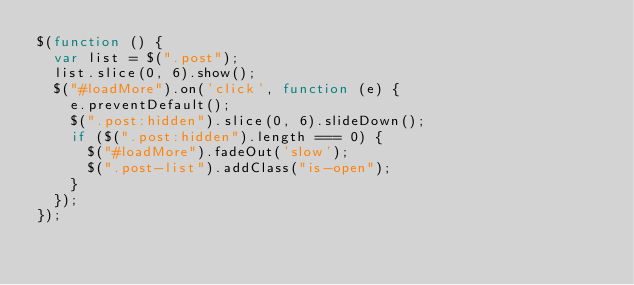Convert code to text. <code><loc_0><loc_0><loc_500><loc_500><_JavaScript_>$(function () {
  var list = $(".post");
  list.slice(0, 6).show();
  $("#loadMore").on('click', function (e) {
    e.preventDefault();
    $(".post:hidden").slice(0, 6).slideDown();
    if ($(".post:hidden").length === 0) {
      $("#loadMore").fadeOut('slow');
      $(".post-list").addClass("is-open");
    }
  });
});
</code> 